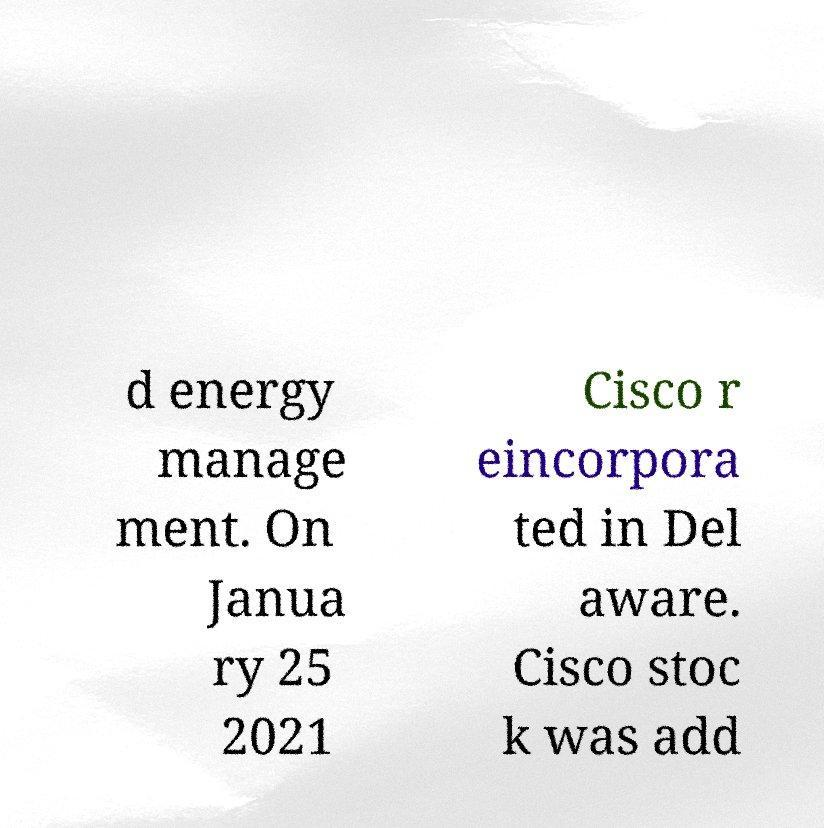Can you accurately transcribe the text from the provided image for me? d energy manage ment. On Janua ry 25 2021 Cisco r eincorpora ted in Del aware. Cisco stoc k was add 